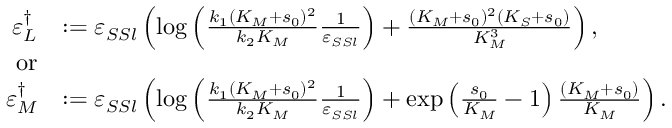<formula> <loc_0><loc_0><loc_500><loc_500>\begin{array} { r l } { \varepsilon _ { L } ^ { \dagger } } & { \colon = \varepsilon _ { S S l } \left ( \log \left ( \frac { k _ { 1 } ( K _ { M } + s _ { 0 } ) ^ { 2 } } { k _ { 2 } K _ { M } } \frac { 1 } { \varepsilon _ { S S l } } \right ) + \frac { ( K _ { M } + s _ { 0 } ) ^ { 2 } ( K _ { S } + s _ { 0 } ) } { K _ { M } ^ { 3 } } \right ) , } \\ { o r } \\ { \varepsilon _ { M } ^ { \dagger } } & { \colon = \varepsilon _ { S S l } \left ( \log \left ( \frac { k _ { 1 } ( K _ { M } + s _ { 0 } ) ^ { 2 } } { k _ { 2 } K _ { M } } \frac { 1 } { \varepsilon _ { S S l } } \right ) + \exp \left ( \frac { s _ { 0 } } { K _ { M } } - 1 \right ) \frac { ( K _ { M } + s _ { 0 } ) } { K _ { M } } \right ) . } \end{array}</formula> 